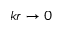Convert formula to latex. <formula><loc_0><loc_0><loc_500><loc_500>k r \to 0</formula> 